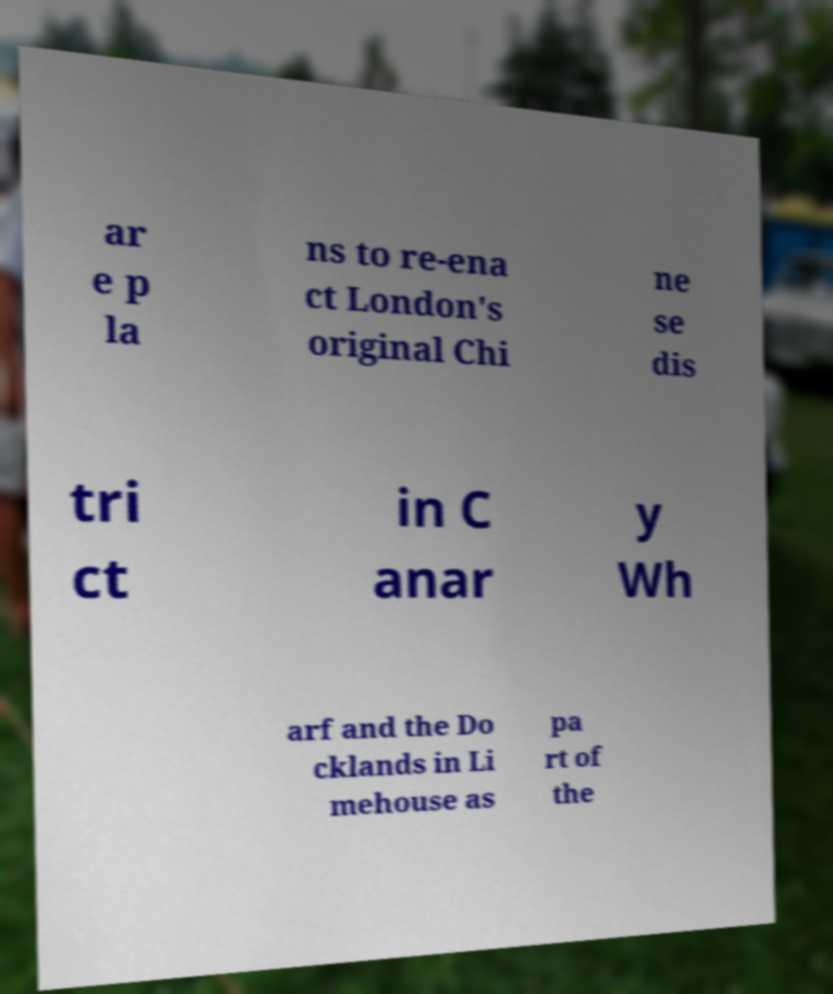What messages or text are displayed in this image? I need them in a readable, typed format. ar e p la ns to re-ena ct London's original Chi ne se dis tri ct in C anar y Wh arf and the Do cklands in Li mehouse as pa rt of the 